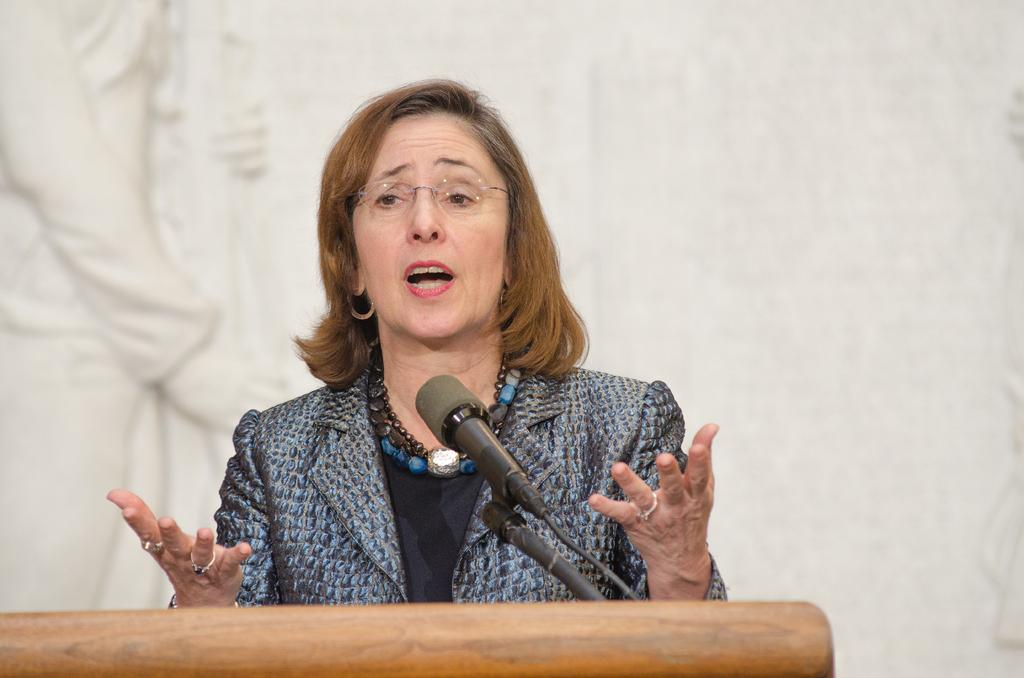Who is the main subject in the image? There is a woman in the image. What is the woman wearing? The woman is wearing spectacles. What is the woman doing in the image? The woman is talking. What object is in front of the woman? There is a microphone in front of the woman. What is the microphone placed on? The microphone is on a wooden surface. What color is the background of the image? The background of the image is white. Can you see any cattle in the image? No, there are no cattle present in the image. Is there a window visible in the image? No, there is no window visible in the image. 